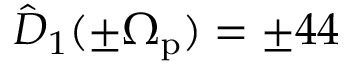<formula> <loc_0><loc_0><loc_500><loc_500>\hat { D } _ { 1 } ( \pm \Omega _ { p } ) = \pm 4 4</formula> 